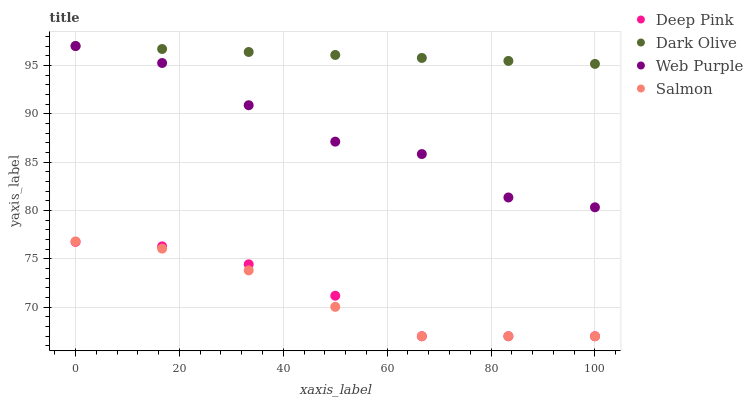Does Salmon have the minimum area under the curve?
Answer yes or no. Yes. Does Dark Olive have the maximum area under the curve?
Answer yes or no. Yes. Does Web Purple have the minimum area under the curve?
Answer yes or no. No. Does Web Purple have the maximum area under the curve?
Answer yes or no. No. Is Dark Olive the smoothest?
Answer yes or no. Yes. Is Web Purple the roughest?
Answer yes or no. Yes. Is Deep Pink the smoothest?
Answer yes or no. No. Is Deep Pink the roughest?
Answer yes or no. No. Does Deep Pink have the lowest value?
Answer yes or no. Yes. Does Web Purple have the lowest value?
Answer yes or no. No. Does Web Purple have the highest value?
Answer yes or no. Yes. Does Deep Pink have the highest value?
Answer yes or no. No. Is Salmon less than Dark Olive?
Answer yes or no. Yes. Is Dark Olive greater than Salmon?
Answer yes or no. Yes. Does Web Purple intersect Dark Olive?
Answer yes or no. Yes. Is Web Purple less than Dark Olive?
Answer yes or no. No. Is Web Purple greater than Dark Olive?
Answer yes or no. No. Does Salmon intersect Dark Olive?
Answer yes or no. No. 